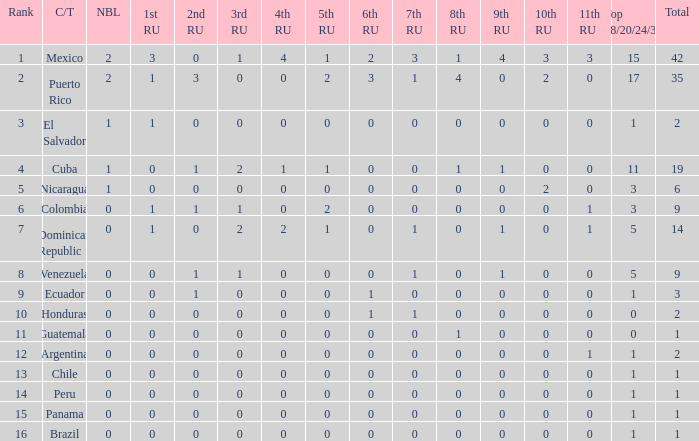What is the 3rd runner-up of the country with more than 0 9th runner-up, an 11th runner-up of 0, and the 1st runner-up greater than 0? None. 